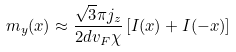Convert formula to latex. <formula><loc_0><loc_0><loc_500><loc_500>m _ { y } ( x ) \approx \frac { \sqrt { 3 } \pi j _ { z } } { 2 d v _ { F } \chi } \left [ I ( x ) + I ( - x ) \right ]</formula> 